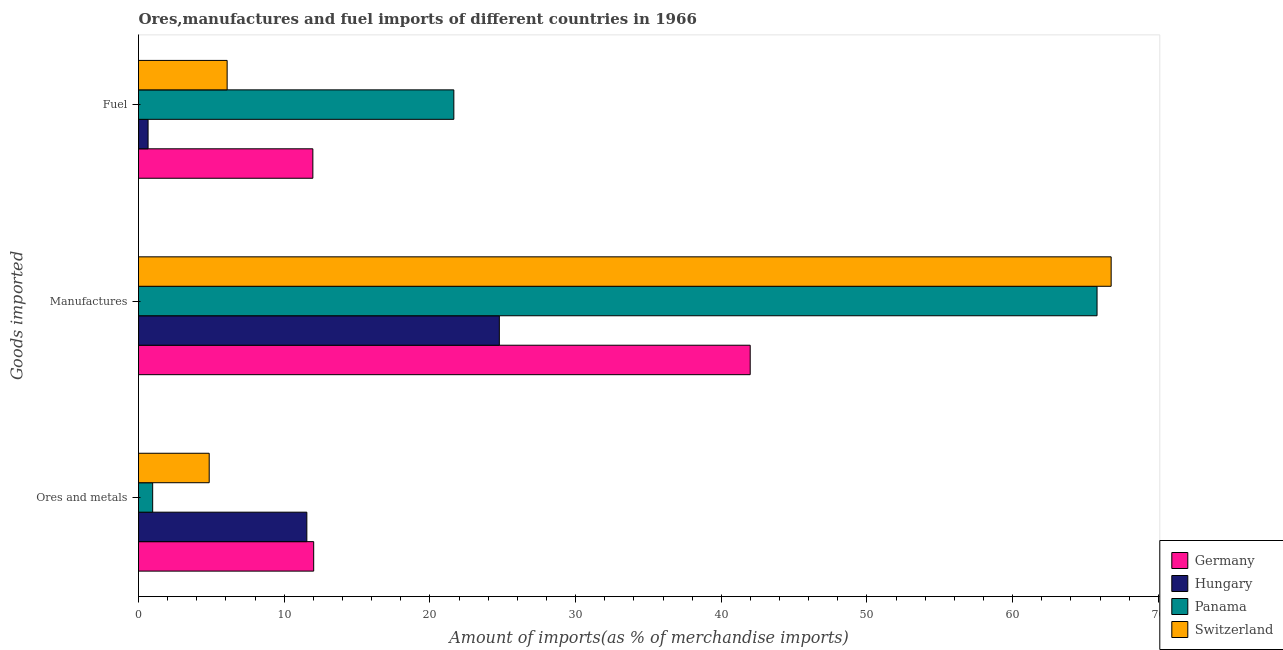How many different coloured bars are there?
Keep it short and to the point. 4. How many groups of bars are there?
Make the answer very short. 3. Are the number of bars on each tick of the Y-axis equal?
Make the answer very short. Yes. How many bars are there on the 1st tick from the top?
Your response must be concise. 4. What is the label of the 3rd group of bars from the top?
Ensure brevity in your answer.  Ores and metals. What is the percentage of fuel imports in Hungary?
Make the answer very short. 0.66. Across all countries, what is the maximum percentage of manufactures imports?
Provide a short and direct response. 66.76. Across all countries, what is the minimum percentage of fuel imports?
Your answer should be compact. 0.66. In which country was the percentage of ores and metals imports maximum?
Ensure brevity in your answer.  Germany. In which country was the percentage of manufactures imports minimum?
Provide a short and direct response. Hungary. What is the total percentage of manufactures imports in the graph?
Give a very brief answer. 199.3. What is the difference between the percentage of manufactures imports in Switzerland and that in Germany?
Offer a terse response. 24.77. What is the difference between the percentage of ores and metals imports in Switzerland and the percentage of fuel imports in Germany?
Provide a succinct answer. -7.12. What is the average percentage of ores and metals imports per country?
Your answer should be very brief. 7.35. What is the difference between the percentage of fuel imports and percentage of ores and metals imports in Panama?
Ensure brevity in your answer.  20.67. In how many countries, is the percentage of manufactures imports greater than 56 %?
Ensure brevity in your answer.  2. What is the ratio of the percentage of manufactures imports in Switzerland to that in Germany?
Provide a succinct answer. 1.59. Is the percentage of manufactures imports in Germany less than that in Switzerland?
Ensure brevity in your answer.  Yes. Is the difference between the percentage of fuel imports in Switzerland and Hungary greater than the difference between the percentage of ores and metals imports in Switzerland and Hungary?
Give a very brief answer. Yes. What is the difference between the highest and the second highest percentage of ores and metals imports?
Keep it short and to the point. 0.47. What is the difference between the highest and the lowest percentage of fuel imports?
Your answer should be compact. 20.99. In how many countries, is the percentage of fuel imports greater than the average percentage of fuel imports taken over all countries?
Ensure brevity in your answer.  2. Is the sum of the percentage of fuel imports in Germany and Panama greater than the maximum percentage of ores and metals imports across all countries?
Give a very brief answer. Yes. What does the 1st bar from the top in Fuel represents?
Your response must be concise. Switzerland. Is it the case that in every country, the sum of the percentage of ores and metals imports and percentage of manufactures imports is greater than the percentage of fuel imports?
Your response must be concise. Yes. How many bars are there?
Ensure brevity in your answer.  12. How many countries are there in the graph?
Offer a terse response. 4. What is the difference between two consecutive major ticks on the X-axis?
Your response must be concise. 10. Does the graph contain grids?
Ensure brevity in your answer.  No. Where does the legend appear in the graph?
Keep it short and to the point. Bottom right. How many legend labels are there?
Your answer should be very brief. 4. How are the legend labels stacked?
Your response must be concise. Vertical. What is the title of the graph?
Keep it short and to the point. Ores,manufactures and fuel imports of different countries in 1966. Does "Jordan" appear as one of the legend labels in the graph?
Your answer should be compact. No. What is the label or title of the X-axis?
Provide a short and direct response. Amount of imports(as % of merchandise imports). What is the label or title of the Y-axis?
Your response must be concise. Goods imported. What is the Amount of imports(as % of merchandise imports) in Germany in Ores and metals?
Provide a short and direct response. 12.02. What is the Amount of imports(as % of merchandise imports) of Hungary in Ores and metals?
Your response must be concise. 11.55. What is the Amount of imports(as % of merchandise imports) of Panama in Ores and metals?
Your answer should be compact. 0.97. What is the Amount of imports(as % of merchandise imports) in Switzerland in Ores and metals?
Offer a terse response. 4.85. What is the Amount of imports(as % of merchandise imports) in Germany in Manufactures?
Provide a short and direct response. 41.98. What is the Amount of imports(as % of merchandise imports) of Hungary in Manufactures?
Ensure brevity in your answer.  24.77. What is the Amount of imports(as % of merchandise imports) of Panama in Manufactures?
Your answer should be compact. 65.79. What is the Amount of imports(as % of merchandise imports) in Switzerland in Manufactures?
Ensure brevity in your answer.  66.76. What is the Amount of imports(as % of merchandise imports) of Germany in Fuel?
Your answer should be very brief. 11.97. What is the Amount of imports(as % of merchandise imports) in Hungary in Fuel?
Your answer should be very brief. 0.66. What is the Amount of imports(as % of merchandise imports) of Panama in Fuel?
Your answer should be compact. 21.64. What is the Amount of imports(as % of merchandise imports) of Switzerland in Fuel?
Offer a terse response. 6.08. Across all Goods imported, what is the maximum Amount of imports(as % of merchandise imports) of Germany?
Ensure brevity in your answer.  41.98. Across all Goods imported, what is the maximum Amount of imports(as % of merchandise imports) of Hungary?
Your answer should be very brief. 24.77. Across all Goods imported, what is the maximum Amount of imports(as % of merchandise imports) of Panama?
Offer a very short reply. 65.79. Across all Goods imported, what is the maximum Amount of imports(as % of merchandise imports) of Switzerland?
Provide a short and direct response. 66.76. Across all Goods imported, what is the minimum Amount of imports(as % of merchandise imports) of Germany?
Your answer should be compact. 11.97. Across all Goods imported, what is the minimum Amount of imports(as % of merchandise imports) of Hungary?
Keep it short and to the point. 0.66. Across all Goods imported, what is the minimum Amount of imports(as % of merchandise imports) in Panama?
Make the answer very short. 0.97. Across all Goods imported, what is the minimum Amount of imports(as % of merchandise imports) of Switzerland?
Offer a terse response. 4.85. What is the total Amount of imports(as % of merchandise imports) of Germany in the graph?
Your response must be concise. 65.98. What is the total Amount of imports(as % of merchandise imports) of Hungary in the graph?
Give a very brief answer. 36.98. What is the total Amount of imports(as % of merchandise imports) in Panama in the graph?
Give a very brief answer. 88.41. What is the total Amount of imports(as % of merchandise imports) of Switzerland in the graph?
Provide a succinct answer. 77.69. What is the difference between the Amount of imports(as % of merchandise imports) in Germany in Ores and metals and that in Manufactures?
Give a very brief answer. -29.96. What is the difference between the Amount of imports(as % of merchandise imports) of Hungary in Ores and metals and that in Manufactures?
Offer a terse response. -13.21. What is the difference between the Amount of imports(as % of merchandise imports) of Panama in Ores and metals and that in Manufactures?
Keep it short and to the point. -64.82. What is the difference between the Amount of imports(as % of merchandise imports) in Switzerland in Ores and metals and that in Manufactures?
Offer a terse response. -61.91. What is the difference between the Amount of imports(as % of merchandise imports) of Germany in Ores and metals and that in Fuel?
Your answer should be very brief. 0.06. What is the difference between the Amount of imports(as % of merchandise imports) of Hungary in Ores and metals and that in Fuel?
Offer a terse response. 10.9. What is the difference between the Amount of imports(as % of merchandise imports) of Panama in Ores and metals and that in Fuel?
Ensure brevity in your answer.  -20.67. What is the difference between the Amount of imports(as % of merchandise imports) in Switzerland in Ores and metals and that in Fuel?
Your answer should be compact. -1.23. What is the difference between the Amount of imports(as % of merchandise imports) in Germany in Manufactures and that in Fuel?
Your answer should be compact. 30.02. What is the difference between the Amount of imports(as % of merchandise imports) of Hungary in Manufactures and that in Fuel?
Your answer should be very brief. 24.11. What is the difference between the Amount of imports(as % of merchandise imports) of Panama in Manufactures and that in Fuel?
Offer a terse response. 44.15. What is the difference between the Amount of imports(as % of merchandise imports) in Switzerland in Manufactures and that in Fuel?
Give a very brief answer. 60.68. What is the difference between the Amount of imports(as % of merchandise imports) in Germany in Ores and metals and the Amount of imports(as % of merchandise imports) in Hungary in Manufactures?
Make the answer very short. -12.74. What is the difference between the Amount of imports(as % of merchandise imports) of Germany in Ores and metals and the Amount of imports(as % of merchandise imports) of Panama in Manufactures?
Your answer should be compact. -53.77. What is the difference between the Amount of imports(as % of merchandise imports) in Germany in Ores and metals and the Amount of imports(as % of merchandise imports) in Switzerland in Manufactures?
Your answer should be compact. -54.73. What is the difference between the Amount of imports(as % of merchandise imports) in Hungary in Ores and metals and the Amount of imports(as % of merchandise imports) in Panama in Manufactures?
Provide a short and direct response. -54.24. What is the difference between the Amount of imports(as % of merchandise imports) in Hungary in Ores and metals and the Amount of imports(as % of merchandise imports) in Switzerland in Manufactures?
Offer a very short reply. -55.2. What is the difference between the Amount of imports(as % of merchandise imports) in Panama in Ores and metals and the Amount of imports(as % of merchandise imports) in Switzerland in Manufactures?
Offer a terse response. -65.79. What is the difference between the Amount of imports(as % of merchandise imports) of Germany in Ores and metals and the Amount of imports(as % of merchandise imports) of Hungary in Fuel?
Give a very brief answer. 11.37. What is the difference between the Amount of imports(as % of merchandise imports) in Germany in Ores and metals and the Amount of imports(as % of merchandise imports) in Panama in Fuel?
Offer a very short reply. -9.62. What is the difference between the Amount of imports(as % of merchandise imports) of Germany in Ores and metals and the Amount of imports(as % of merchandise imports) of Switzerland in Fuel?
Offer a terse response. 5.94. What is the difference between the Amount of imports(as % of merchandise imports) of Hungary in Ores and metals and the Amount of imports(as % of merchandise imports) of Panama in Fuel?
Offer a terse response. -10.09. What is the difference between the Amount of imports(as % of merchandise imports) in Hungary in Ores and metals and the Amount of imports(as % of merchandise imports) in Switzerland in Fuel?
Provide a succinct answer. 5.47. What is the difference between the Amount of imports(as % of merchandise imports) in Panama in Ores and metals and the Amount of imports(as % of merchandise imports) in Switzerland in Fuel?
Offer a very short reply. -5.11. What is the difference between the Amount of imports(as % of merchandise imports) in Germany in Manufactures and the Amount of imports(as % of merchandise imports) in Hungary in Fuel?
Keep it short and to the point. 41.33. What is the difference between the Amount of imports(as % of merchandise imports) in Germany in Manufactures and the Amount of imports(as % of merchandise imports) in Panama in Fuel?
Your answer should be very brief. 20.34. What is the difference between the Amount of imports(as % of merchandise imports) in Germany in Manufactures and the Amount of imports(as % of merchandise imports) in Switzerland in Fuel?
Offer a very short reply. 35.9. What is the difference between the Amount of imports(as % of merchandise imports) of Hungary in Manufactures and the Amount of imports(as % of merchandise imports) of Panama in Fuel?
Your answer should be compact. 3.12. What is the difference between the Amount of imports(as % of merchandise imports) in Hungary in Manufactures and the Amount of imports(as % of merchandise imports) in Switzerland in Fuel?
Ensure brevity in your answer.  18.68. What is the difference between the Amount of imports(as % of merchandise imports) in Panama in Manufactures and the Amount of imports(as % of merchandise imports) in Switzerland in Fuel?
Provide a short and direct response. 59.71. What is the average Amount of imports(as % of merchandise imports) in Germany per Goods imported?
Offer a terse response. 21.99. What is the average Amount of imports(as % of merchandise imports) of Hungary per Goods imported?
Provide a succinct answer. 12.33. What is the average Amount of imports(as % of merchandise imports) in Panama per Goods imported?
Offer a terse response. 29.47. What is the average Amount of imports(as % of merchandise imports) of Switzerland per Goods imported?
Offer a very short reply. 25.9. What is the difference between the Amount of imports(as % of merchandise imports) in Germany and Amount of imports(as % of merchandise imports) in Hungary in Ores and metals?
Provide a short and direct response. 0.47. What is the difference between the Amount of imports(as % of merchandise imports) of Germany and Amount of imports(as % of merchandise imports) of Panama in Ores and metals?
Offer a terse response. 11.05. What is the difference between the Amount of imports(as % of merchandise imports) of Germany and Amount of imports(as % of merchandise imports) of Switzerland in Ores and metals?
Offer a very short reply. 7.17. What is the difference between the Amount of imports(as % of merchandise imports) of Hungary and Amount of imports(as % of merchandise imports) of Panama in Ores and metals?
Provide a short and direct response. 10.58. What is the difference between the Amount of imports(as % of merchandise imports) of Hungary and Amount of imports(as % of merchandise imports) of Switzerland in Ores and metals?
Provide a succinct answer. 6.7. What is the difference between the Amount of imports(as % of merchandise imports) of Panama and Amount of imports(as % of merchandise imports) of Switzerland in Ores and metals?
Your answer should be compact. -3.88. What is the difference between the Amount of imports(as % of merchandise imports) of Germany and Amount of imports(as % of merchandise imports) of Hungary in Manufactures?
Keep it short and to the point. 17.22. What is the difference between the Amount of imports(as % of merchandise imports) in Germany and Amount of imports(as % of merchandise imports) in Panama in Manufactures?
Make the answer very short. -23.81. What is the difference between the Amount of imports(as % of merchandise imports) in Germany and Amount of imports(as % of merchandise imports) in Switzerland in Manufactures?
Your answer should be very brief. -24.77. What is the difference between the Amount of imports(as % of merchandise imports) of Hungary and Amount of imports(as % of merchandise imports) of Panama in Manufactures?
Your answer should be compact. -41.02. What is the difference between the Amount of imports(as % of merchandise imports) of Hungary and Amount of imports(as % of merchandise imports) of Switzerland in Manufactures?
Ensure brevity in your answer.  -41.99. What is the difference between the Amount of imports(as % of merchandise imports) in Panama and Amount of imports(as % of merchandise imports) in Switzerland in Manufactures?
Give a very brief answer. -0.97. What is the difference between the Amount of imports(as % of merchandise imports) of Germany and Amount of imports(as % of merchandise imports) of Hungary in Fuel?
Offer a very short reply. 11.31. What is the difference between the Amount of imports(as % of merchandise imports) of Germany and Amount of imports(as % of merchandise imports) of Panama in Fuel?
Make the answer very short. -9.68. What is the difference between the Amount of imports(as % of merchandise imports) in Germany and Amount of imports(as % of merchandise imports) in Switzerland in Fuel?
Offer a terse response. 5.88. What is the difference between the Amount of imports(as % of merchandise imports) in Hungary and Amount of imports(as % of merchandise imports) in Panama in Fuel?
Your response must be concise. -20.99. What is the difference between the Amount of imports(as % of merchandise imports) in Hungary and Amount of imports(as % of merchandise imports) in Switzerland in Fuel?
Ensure brevity in your answer.  -5.43. What is the difference between the Amount of imports(as % of merchandise imports) of Panama and Amount of imports(as % of merchandise imports) of Switzerland in Fuel?
Ensure brevity in your answer.  15.56. What is the ratio of the Amount of imports(as % of merchandise imports) in Germany in Ores and metals to that in Manufactures?
Offer a terse response. 0.29. What is the ratio of the Amount of imports(as % of merchandise imports) in Hungary in Ores and metals to that in Manufactures?
Keep it short and to the point. 0.47. What is the ratio of the Amount of imports(as % of merchandise imports) in Panama in Ores and metals to that in Manufactures?
Provide a succinct answer. 0.01. What is the ratio of the Amount of imports(as % of merchandise imports) of Switzerland in Ores and metals to that in Manufactures?
Give a very brief answer. 0.07. What is the ratio of the Amount of imports(as % of merchandise imports) in Hungary in Ores and metals to that in Fuel?
Your response must be concise. 17.6. What is the ratio of the Amount of imports(as % of merchandise imports) in Panama in Ores and metals to that in Fuel?
Offer a terse response. 0.04. What is the ratio of the Amount of imports(as % of merchandise imports) of Switzerland in Ores and metals to that in Fuel?
Your answer should be compact. 0.8. What is the ratio of the Amount of imports(as % of merchandise imports) of Germany in Manufactures to that in Fuel?
Your answer should be very brief. 3.51. What is the ratio of the Amount of imports(as % of merchandise imports) of Hungary in Manufactures to that in Fuel?
Your answer should be very brief. 37.73. What is the ratio of the Amount of imports(as % of merchandise imports) of Panama in Manufactures to that in Fuel?
Your response must be concise. 3.04. What is the ratio of the Amount of imports(as % of merchandise imports) in Switzerland in Manufactures to that in Fuel?
Keep it short and to the point. 10.97. What is the difference between the highest and the second highest Amount of imports(as % of merchandise imports) of Germany?
Provide a short and direct response. 29.96. What is the difference between the highest and the second highest Amount of imports(as % of merchandise imports) in Hungary?
Make the answer very short. 13.21. What is the difference between the highest and the second highest Amount of imports(as % of merchandise imports) in Panama?
Keep it short and to the point. 44.15. What is the difference between the highest and the second highest Amount of imports(as % of merchandise imports) in Switzerland?
Your response must be concise. 60.68. What is the difference between the highest and the lowest Amount of imports(as % of merchandise imports) in Germany?
Make the answer very short. 30.02. What is the difference between the highest and the lowest Amount of imports(as % of merchandise imports) of Hungary?
Provide a short and direct response. 24.11. What is the difference between the highest and the lowest Amount of imports(as % of merchandise imports) in Panama?
Give a very brief answer. 64.82. What is the difference between the highest and the lowest Amount of imports(as % of merchandise imports) of Switzerland?
Provide a short and direct response. 61.91. 